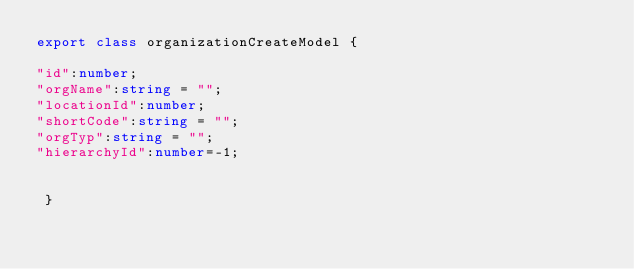Convert code to text. <code><loc_0><loc_0><loc_500><loc_500><_TypeScript_>export class organizationCreateModel {

"id":number;
"orgName":string = "";
"locationId":number;
"shortCode":string = "";
"orgTyp":string = "";
"hierarchyId":number=-1;


 }

 


</code> 